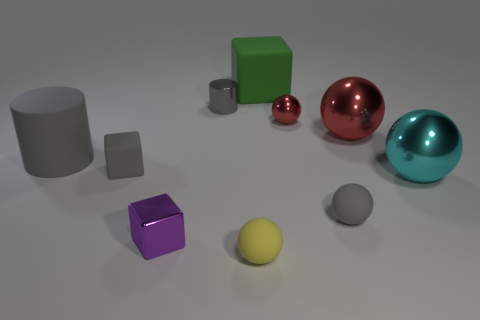Subtract all cyan balls. How many balls are left? 4 Subtract all small gray matte spheres. How many spheres are left? 4 Subtract 1 spheres. How many spheres are left? 4 Subtract all blue balls. Subtract all blue cylinders. How many balls are left? 5 Subtract all cubes. How many objects are left? 7 Subtract all tiny things. Subtract all gray spheres. How many objects are left? 3 Add 2 small matte things. How many small matte things are left? 5 Add 6 large gray objects. How many large gray objects exist? 7 Subtract 0 blue spheres. How many objects are left? 10 